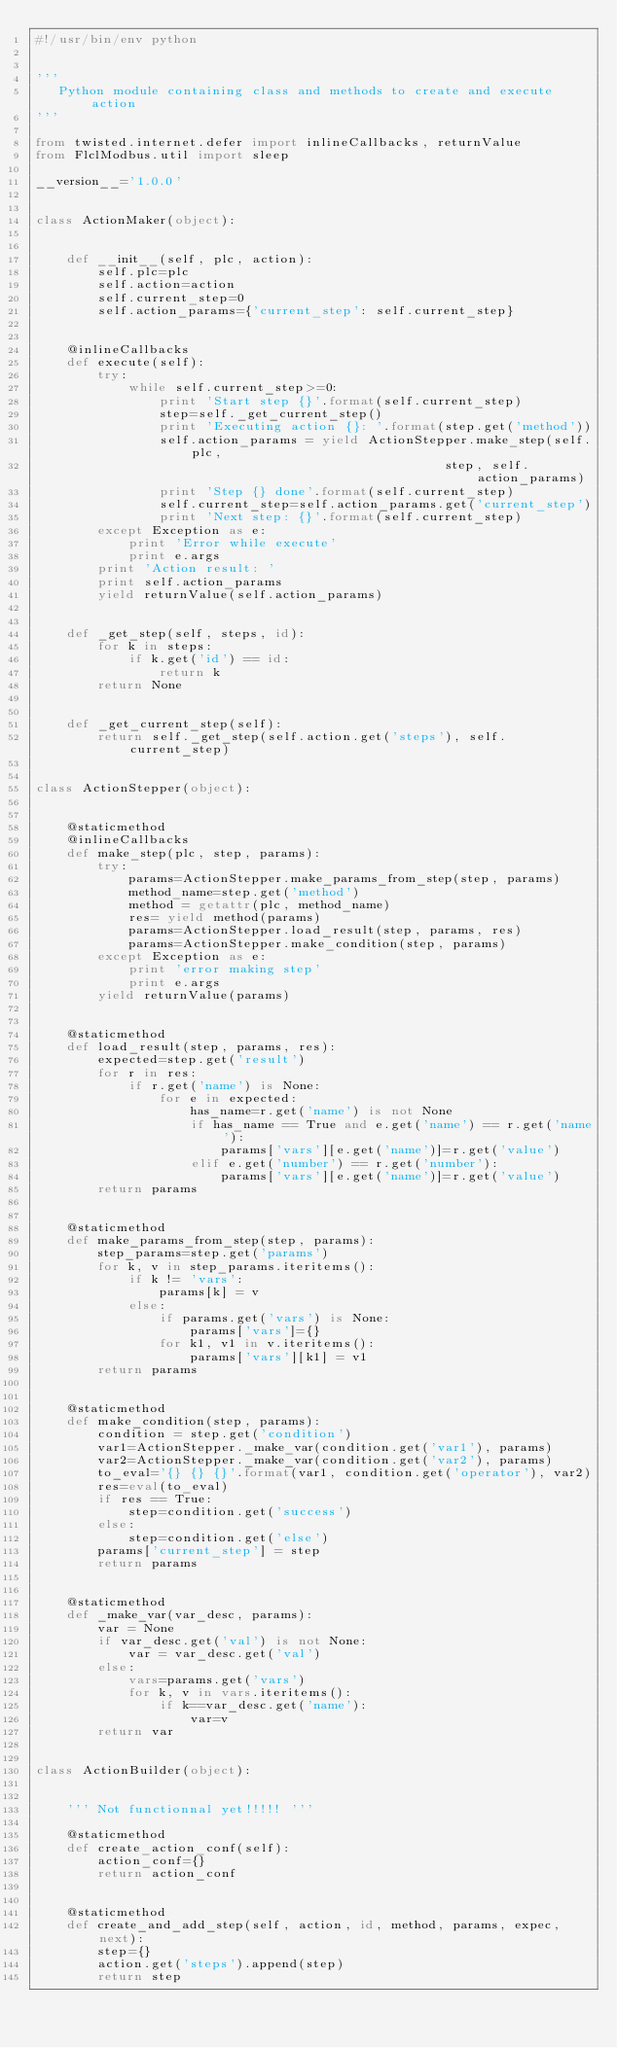Convert code to text. <code><loc_0><loc_0><loc_500><loc_500><_Python_>#!/usr/bin/env python


'''
   Python module containing class and methods to create and execute action
'''

from twisted.internet.defer import inlineCallbacks, returnValue
from FlclModbus.util import sleep

__version__='1.0.0'


class ActionMaker(object):


    def __init__(self, plc, action):
        self.plc=plc
        self.action=action
        self.current_step=0
        self.action_params={'current_step': self.current_step}


    @inlineCallbacks
    def execute(self):
        try:
            while self.current_step>=0:
                print 'Start step {}'.format(self.current_step)
                step=self._get_current_step()
                print 'Executing action {}: '.format(step.get('method'))
                self.action_params = yield ActionStepper.make_step(self.plc,
                                                     step, self.action_params)
                print 'Step {} done'.format(self.current_step)
                self.current_step=self.action_params.get('current_step')
                print 'Next step: {}'.format(self.current_step)
        except Exception as e:
            print 'Error while execute'
            print e.args
        print 'Action result: '
        print self.action_params
        yield returnValue(self.action_params)


    def _get_step(self, steps, id):
        for k in steps:
            if k.get('id') == id:
                return k
        return None


    def _get_current_step(self):
        return self._get_step(self.action.get('steps'), self.current_step)


class ActionStepper(object):


    @staticmethod
    @inlineCallbacks
    def make_step(plc, step, params):
        try:
            params=ActionStepper.make_params_from_step(step, params)
            method_name=step.get('method')
            method = getattr(plc, method_name)
            res= yield method(params)
            params=ActionStepper.load_result(step, params, res)
            params=ActionStepper.make_condition(step, params)
        except Exception as e:
            print 'error making step'
            print e.args
        yield returnValue(params)


    @staticmethod
    def load_result(step, params, res):
        expected=step.get('result')
        for r in res:
            if r.get('name') is None:
                for e in expected:
                    has_name=r.get('name') is not None
                    if has_name == True and e.get('name') == r.get('name'):
                        params['vars'][e.get('name')]=r.get('value')
                    elif e.get('number') == r.get('number'):
                        params['vars'][e.get('name')]=r.get('value')
        return params


    @staticmethod
    def make_params_from_step(step, params):
        step_params=step.get('params')
        for k, v in step_params.iteritems():
            if k != 'vars':
                params[k] = v
            else:
                if params.get('vars') is None:
                    params['vars']={}
                for k1, v1 in v.iteritems():
                    params['vars'][k1] = v1
        return params


    @staticmethod
    def make_condition(step, params):
        condition = step.get('condition')
        var1=ActionStepper._make_var(condition.get('var1'), params)
        var2=ActionStepper._make_var(condition.get('var2'), params)
        to_eval='{} {} {}'.format(var1, condition.get('operator'), var2)
        res=eval(to_eval)
        if res == True:
            step=condition.get('success')
        else:
            step=condition.get('else')
        params['current_step'] = step
        return params


    @staticmethod
    def _make_var(var_desc, params):
        var = None
        if var_desc.get('val') is not None:
            var = var_desc.get('val')
        else:
            vars=params.get('vars')
            for k, v in vars.iteritems():
                if k==var_desc.get('name'):
                    var=v
        return var


class ActionBuilder(object):


    ''' Not functionnal yet!!!!! '''

    @staticmethod
    def create_action_conf(self):
        action_conf={}
        return action_conf


    @staticmethod
    def create_and_add_step(self, action, id, method, params, expec, next):
        step={}
        action.get('steps').append(step)
        return step


</code> 